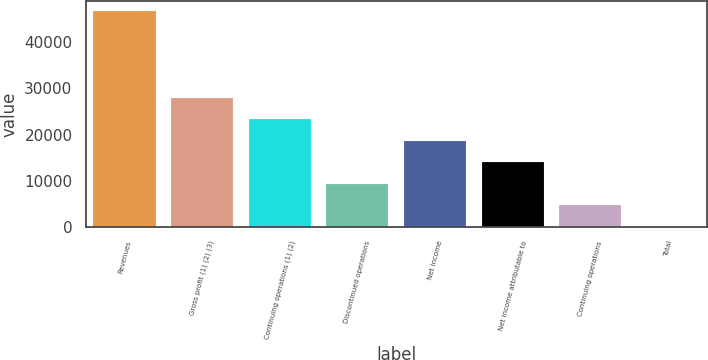Convert chart. <chart><loc_0><loc_0><loc_500><loc_500><bar_chart><fcel>Revenues<fcel>Gross profit (1) (2) (3)<fcel>Continuing operations (1) (2)<fcel>Discontinued operations<fcel>Net income<fcel>Net income attributable to<fcel>Continuing operations<fcel>Total<nl><fcel>46678<fcel>28007.5<fcel>23339.9<fcel>9337.1<fcel>18672.3<fcel>14004.7<fcel>4669.49<fcel>1.88<nl></chart> 